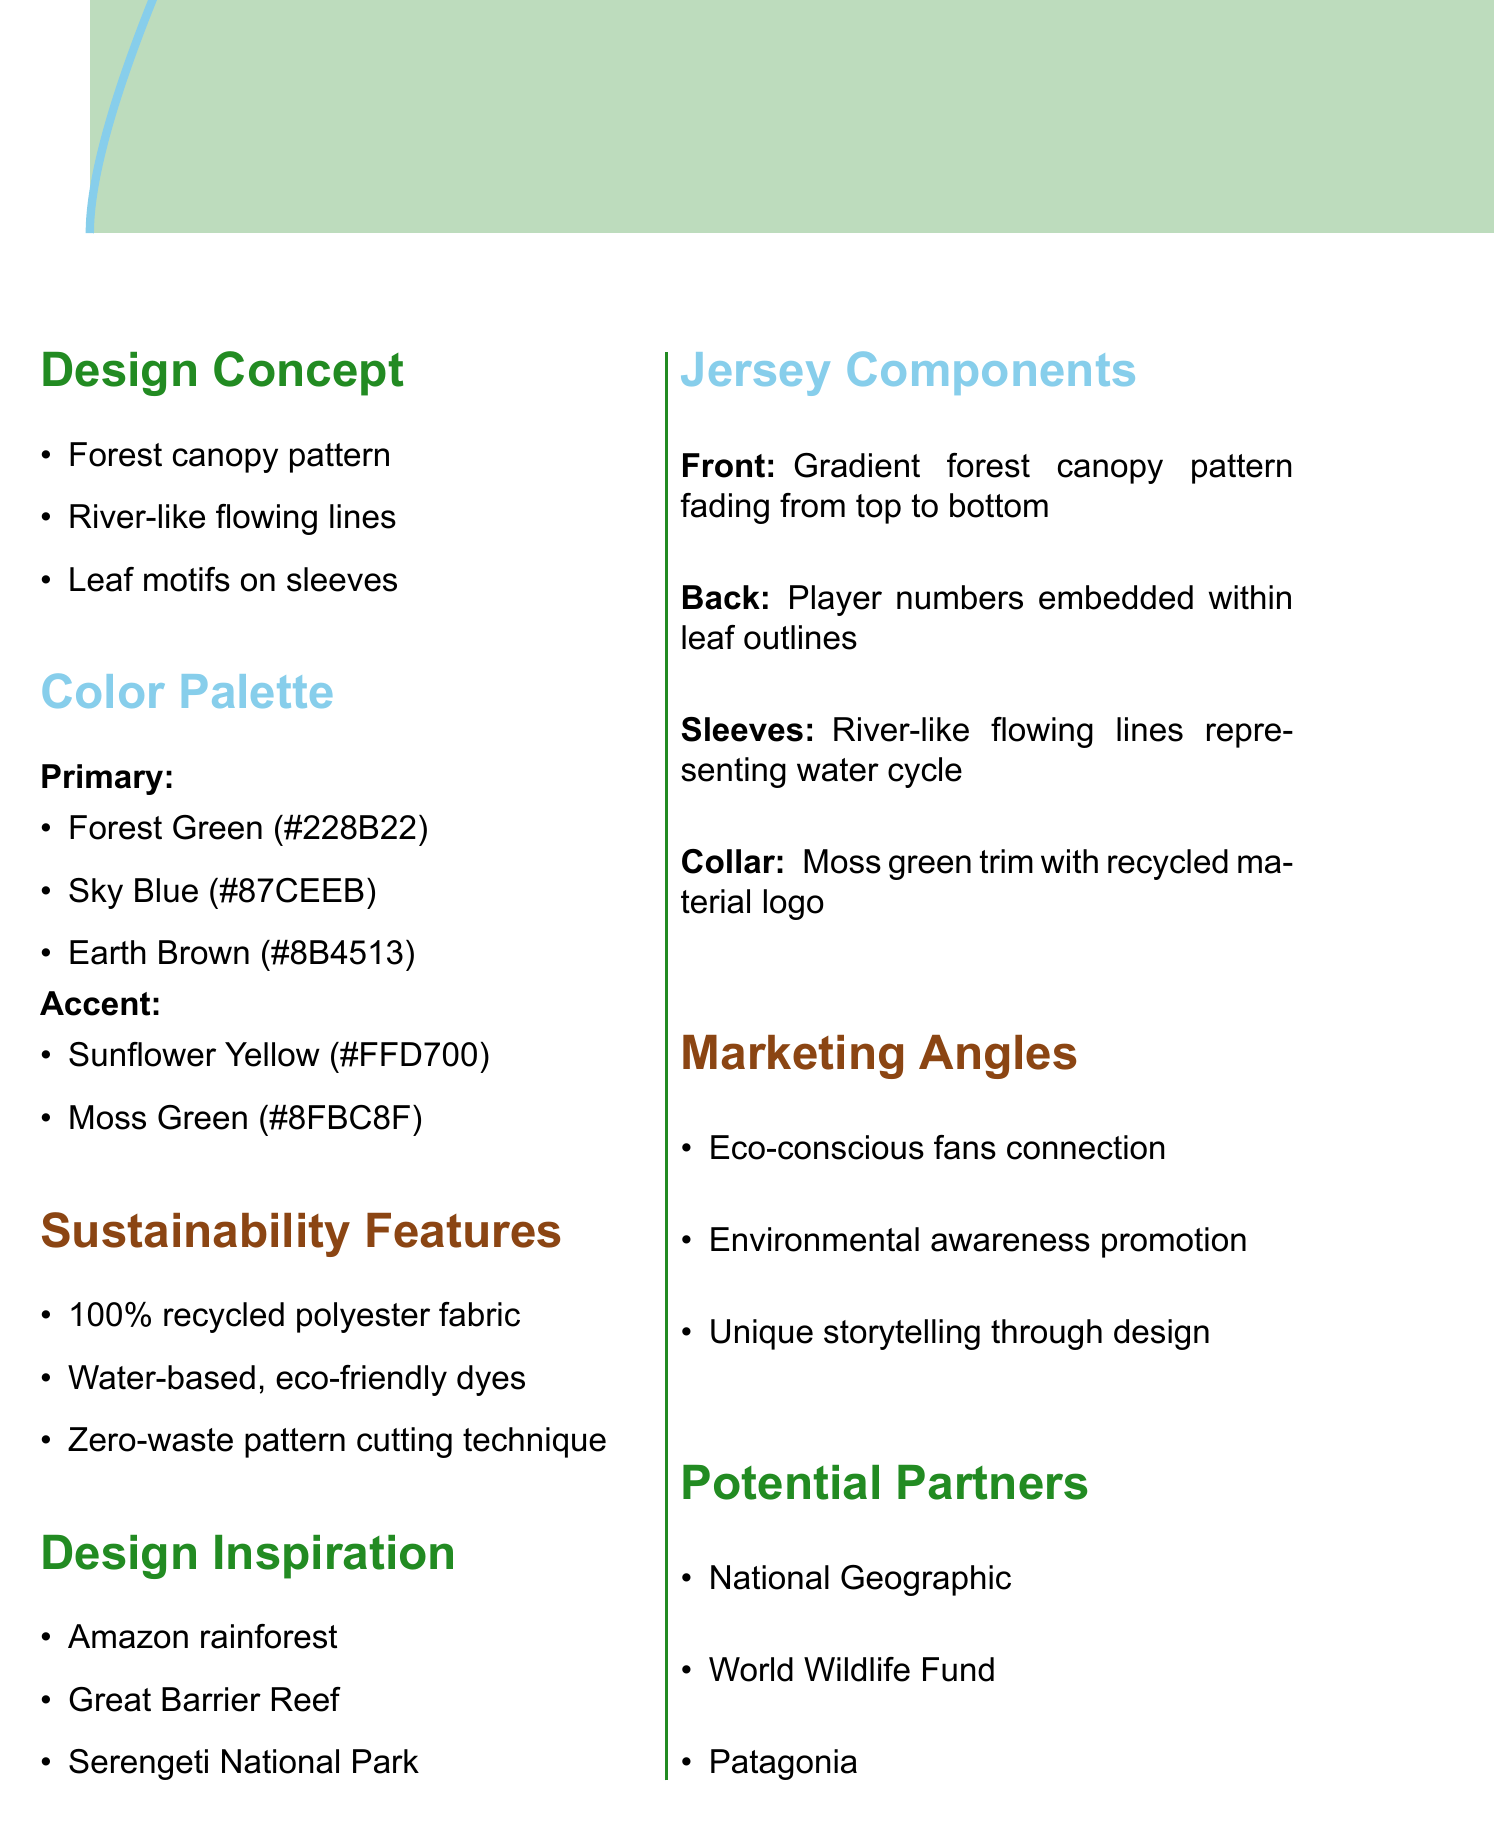What is the main theme of the jersey design? The main theme described in the notes highlights the purpose and style of the jersey, which is categorized as "Nature-inspired sustainable away kit."
Answer: Nature-inspired sustainable away kit What colors are included in the primary color palette? The primary colors are explicitly listed in the document, showing what colors will primarily represent the kit.
Answer: Forest Green, Sky Blue, Earth Brown What sustainability feature involves the fabric used? The document indicates that the jersey is made from a specific type of fabric that supports sustainability.
Answer: 100% recycled polyester fabric Which natural inspiration is mentioned for the design? The document provides a list of specific natural inspirations that influenced the design, giving context to its aesthetic.
Answer: Amazon rainforest What design element is suggested for the back of the jersey? The notes include specific details about the back design, highlighting how player numbers will be represented.
Answer: Player numbers embedded within leaf outlines How many accent colors are specified in the color palette? By reviewing the color palette section, the quantity of accent colors mentioned can be determined.
Answer: Two What marketing angle focuses on fans? The marketing angles in the notes emphasize various strategies for connecting with the fan base, providing insights into the promotional approach.
Answer: Eco-conscious fans connection Which organization is suggested as a potential partner for this project? The document lists potential partners, asserting organizations that could link arms with the project for wider impact.
Answer: National Geographic 